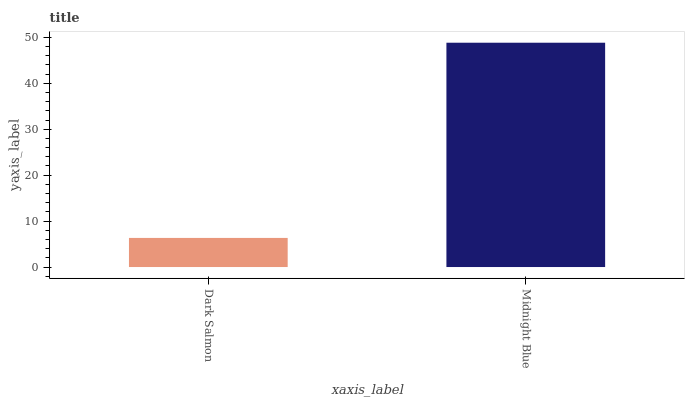Is Dark Salmon the minimum?
Answer yes or no. Yes. Is Midnight Blue the maximum?
Answer yes or no. Yes. Is Midnight Blue the minimum?
Answer yes or no. No. Is Midnight Blue greater than Dark Salmon?
Answer yes or no. Yes. Is Dark Salmon less than Midnight Blue?
Answer yes or no. Yes. Is Dark Salmon greater than Midnight Blue?
Answer yes or no. No. Is Midnight Blue less than Dark Salmon?
Answer yes or no. No. Is Midnight Blue the high median?
Answer yes or no. Yes. Is Dark Salmon the low median?
Answer yes or no. Yes. Is Dark Salmon the high median?
Answer yes or no. No. Is Midnight Blue the low median?
Answer yes or no. No. 